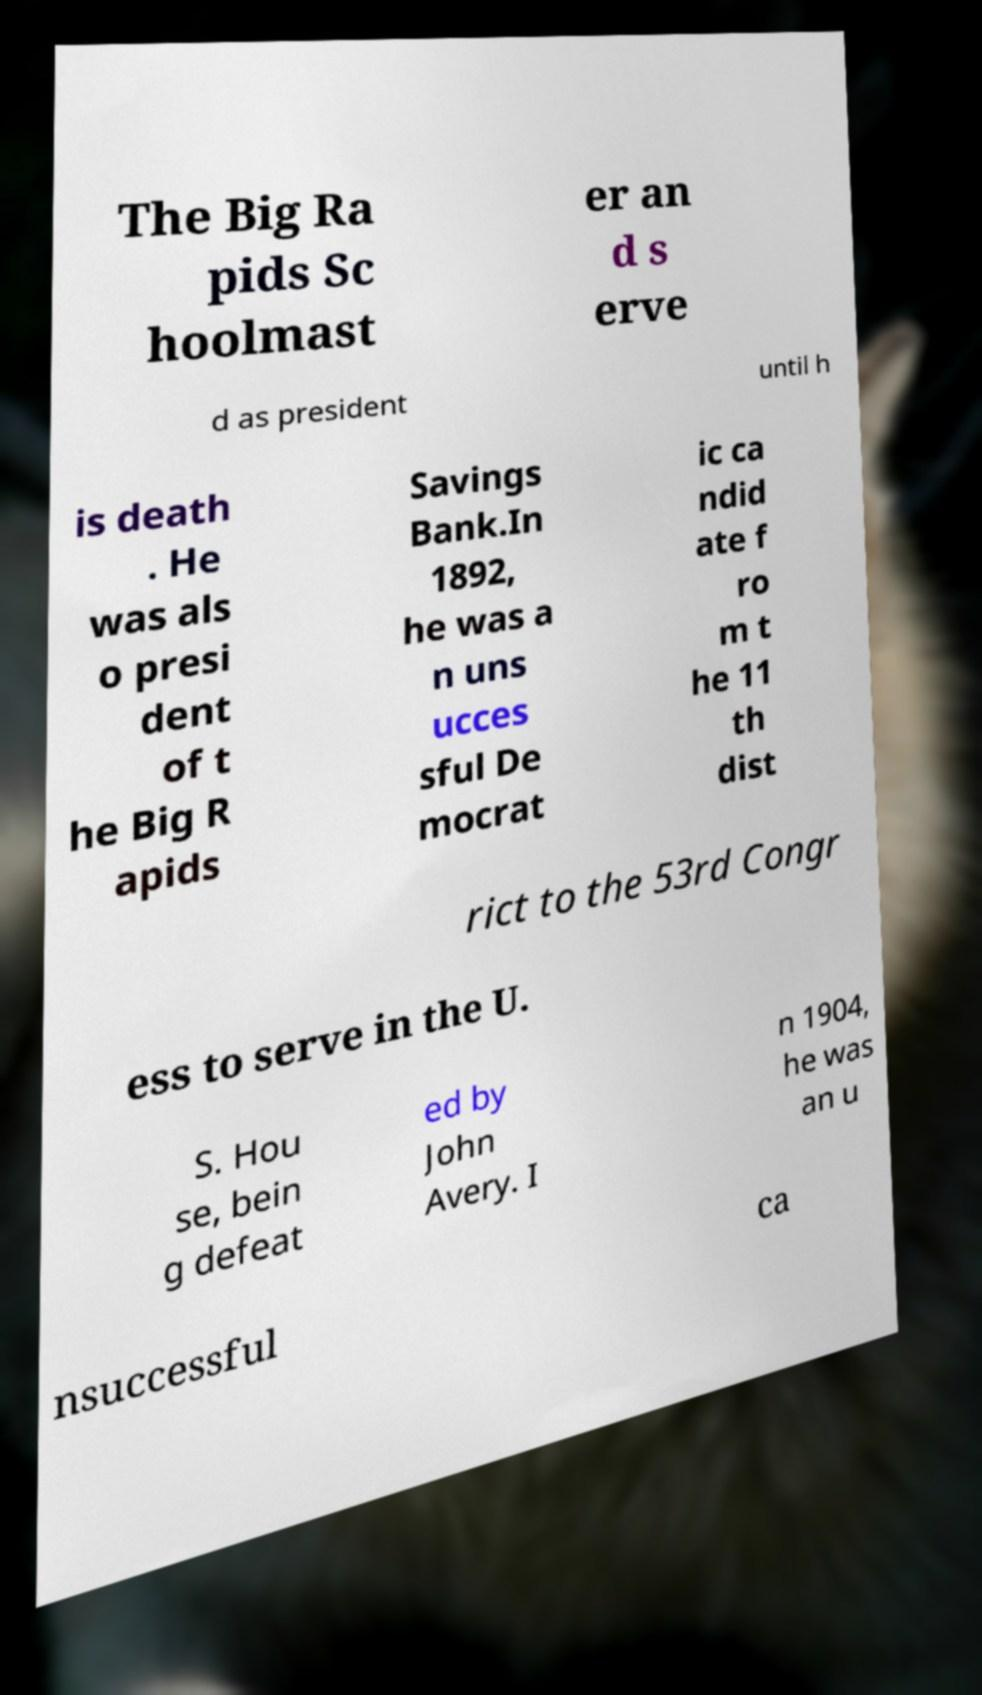For documentation purposes, I need the text within this image transcribed. Could you provide that? The Big Ra pids Sc hoolmast er an d s erve d as president until h is death . He was als o presi dent of t he Big R apids Savings Bank.In 1892, he was a n uns ucces sful De mocrat ic ca ndid ate f ro m t he 11 th dist rict to the 53rd Congr ess to serve in the U. S. Hou se, bein g defeat ed by John Avery. I n 1904, he was an u nsuccessful ca 